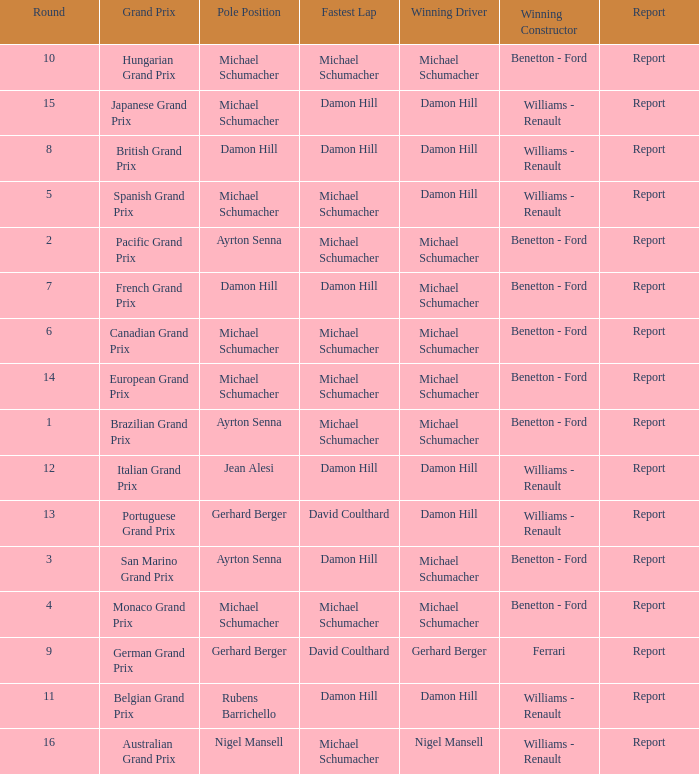Would you mind parsing the complete table? {'header': ['Round', 'Grand Prix', 'Pole Position', 'Fastest Lap', 'Winning Driver', 'Winning Constructor', 'Report'], 'rows': [['10', 'Hungarian Grand Prix', 'Michael Schumacher', 'Michael Schumacher', 'Michael Schumacher', 'Benetton - Ford', 'Report'], ['15', 'Japanese Grand Prix', 'Michael Schumacher', 'Damon Hill', 'Damon Hill', 'Williams - Renault', 'Report'], ['8', 'British Grand Prix', 'Damon Hill', 'Damon Hill', 'Damon Hill', 'Williams - Renault', 'Report'], ['5', 'Spanish Grand Prix', 'Michael Schumacher', 'Michael Schumacher', 'Damon Hill', 'Williams - Renault', 'Report'], ['2', 'Pacific Grand Prix', 'Ayrton Senna', 'Michael Schumacher', 'Michael Schumacher', 'Benetton - Ford', 'Report'], ['7', 'French Grand Prix', 'Damon Hill', 'Damon Hill', 'Michael Schumacher', 'Benetton - Ford', 'Report'], ['6', 'Canadian Grand Prix', 'Michael Schumacher', 'Michael Schumacher', 'Michael Schumacher', 'Benetton - Ford', 'Report'], ['14', 'European Grand Prix', 'Michael Schumacher', 'Michael Schumacher', 'Michael Schumacher', 'Benetton - Ford', 'Report'], ['1', 'Brazilian Grand Prix', 'Ayrton Senna', 'Michael Schumacher', 'Michael Schumacher', 'Benetton - Ford', 'Report'], ['12', 'Italian Grand Prix', 'Jean Alesi', 'Damon Hill', 'Damon Hill', 'Williams - Renault', 'Report'], ['13', 'Portuguese Grand Prix', 'Gerhard Berger', 'David Coulthard', 'Damon Hill', 'Williams - Renault', 'Report'], ['3', 'San Marino Grand Prix', 'Ayrton Senna', 'Damon Hill', 'Michael Schumacher', 'Benetton - Ford', 'Report'], ['4', 'Monaco Grand Prix', 'Michael Schumacher', 'Michael Schumacher', 'Michael Schumacher', 'Benetton - Ford', 'Report'], ['9', 'German Grand Prix', 'Gerhard Berger', 'David Coulthard', 'Gerhard Berger', 'Ferrari', 'Report'], ['11', 'Belgian Grand Prix', 'Rubens Barrichello', 'Damon Hill', 'Damon Hill', 'Williams - Renault', 'Report'], ['16', 'Australian Grand Prix', 'Nigel Mansell', 'Michael Schumacher', 'Nigel Mansell', 'Williams - Renault', 'Report']]} Name the lowest round for when pole position and winning driver is michael schumacher 4.0. 